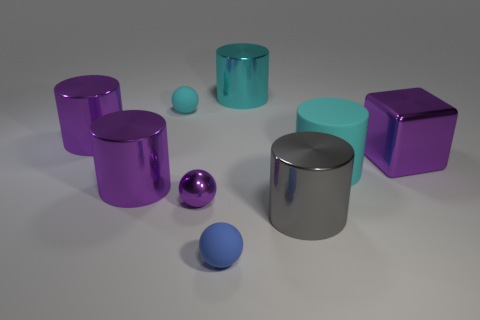Subtract all gray cylinders. How many cylinders are left? 4 Subtract all gray cylinders. How many cylinders are left? 4 Subtract all yellow cylinders. Subtract all gray spheres. How many cylinders are left? 5 Add 1 purple blocks. How many objects exist? 10 Subtract all balls. How many objects are left? 6 Add 2 metallic cylinders. How many metallic cylinders exist? 6 Subtract 1 purple spheres. How many objects are left? 8 Subtract all big gray metal spheres. Subtract all large things. How many objects are left? 3 Add 9 large gray objects. How many large gray objects are left? 10 